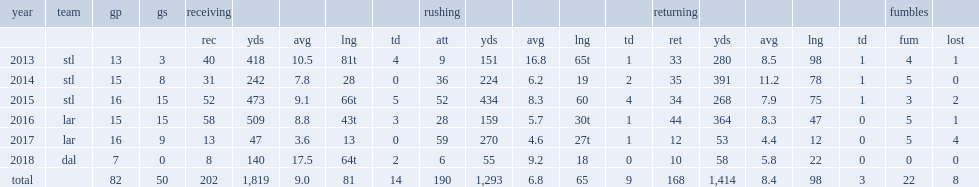How many receiving yards did tavon austin get in 2015? 473.0. How many return yards did tavon austin finish with in 2014? 391.0. 